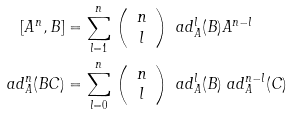<formula> <loc_0><loc_0><loc_500><loc_500>[ A ^ { n } , B ] & = \sum _ { l = 1 } ^ { n } \, \left ( \begin{array} { c } n \\ l \end{array} \right ) \ a d _ { A } ^ { l } ( B ) A ^ { n - l } \\ \ a d _ { A } ^ { n } ( B C ) & = \sum _ { l = 0 } ^ { n } \, \left ( \begin{array} { c } n \\ l \end{array} \right ) \ a d _ { A } ^ { l } ( B ) \ a d _ { A } ^ { n - l } ( C )</formula> 